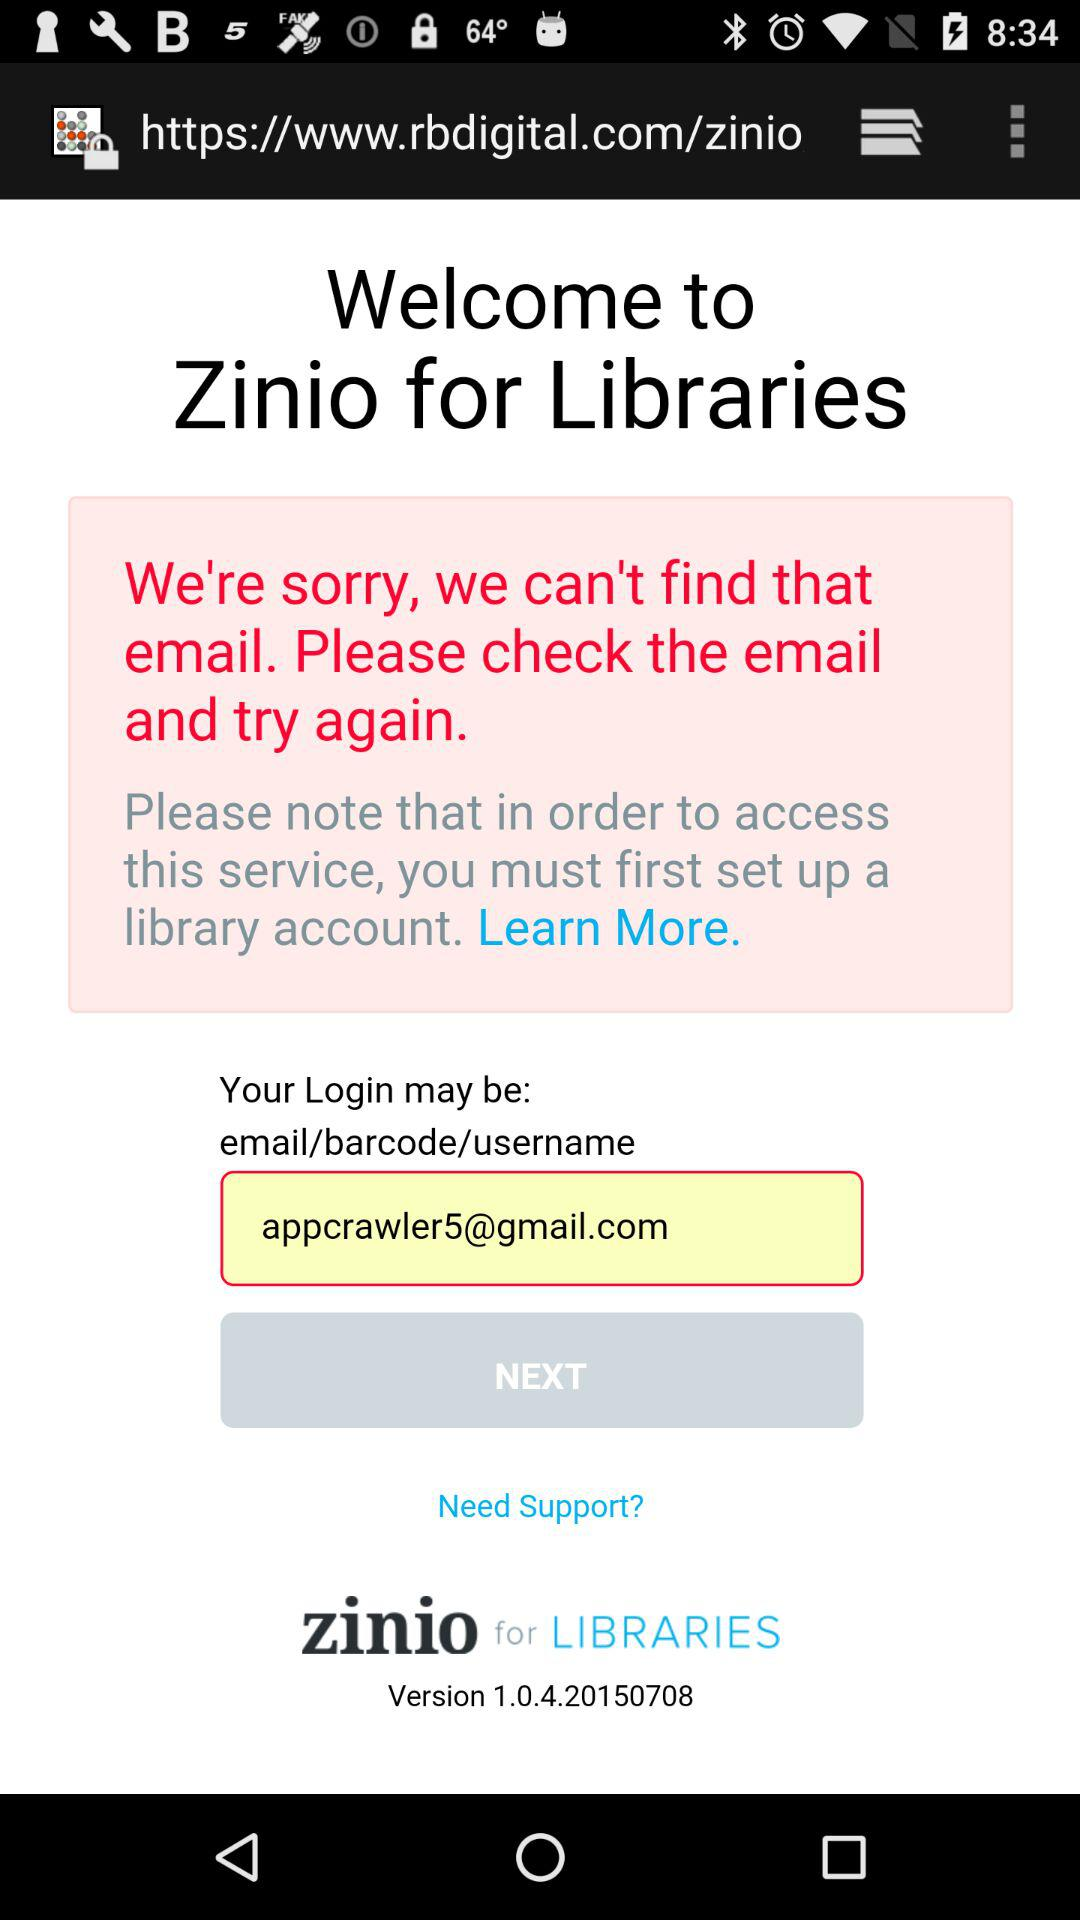What is required to be entered to log in? To log in, an email address or a barcode or a username is required. 